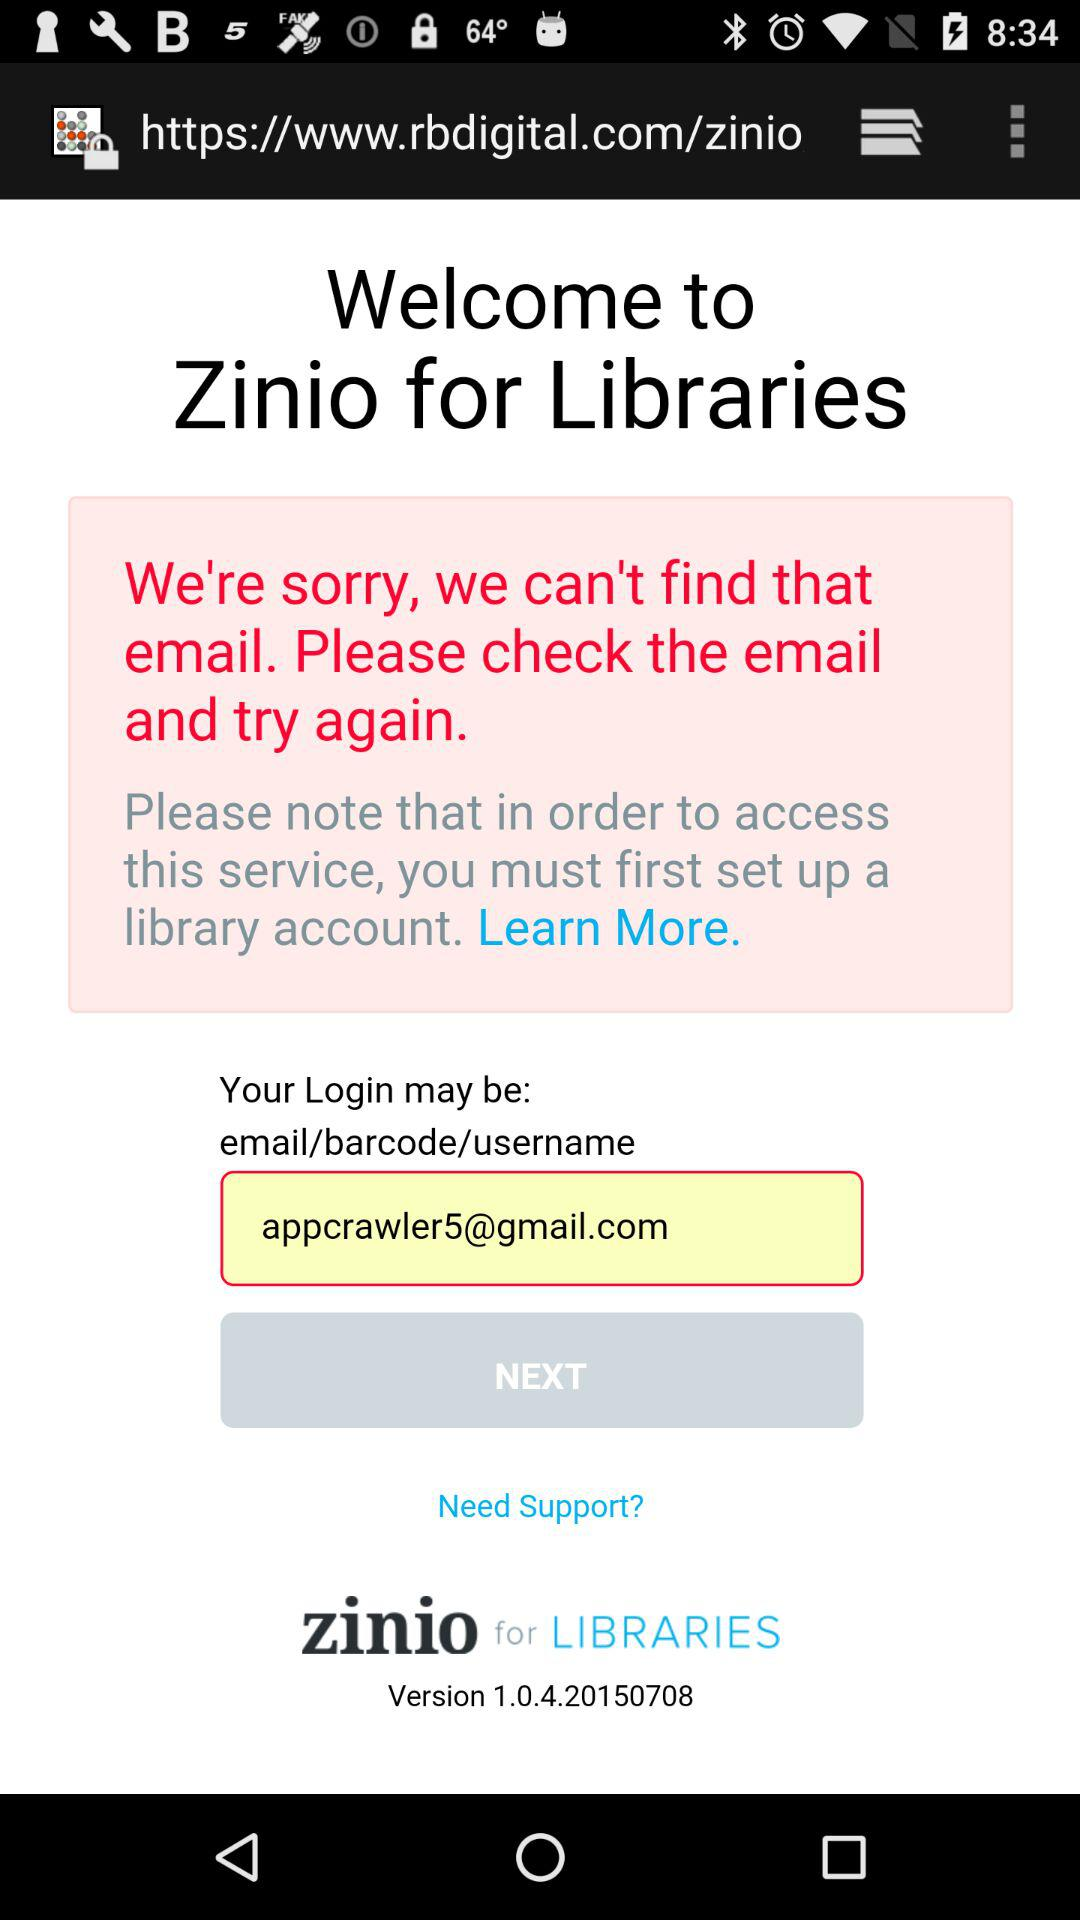What is required to be entered to log in? To log in, an email address or a barcode or a username is required. 